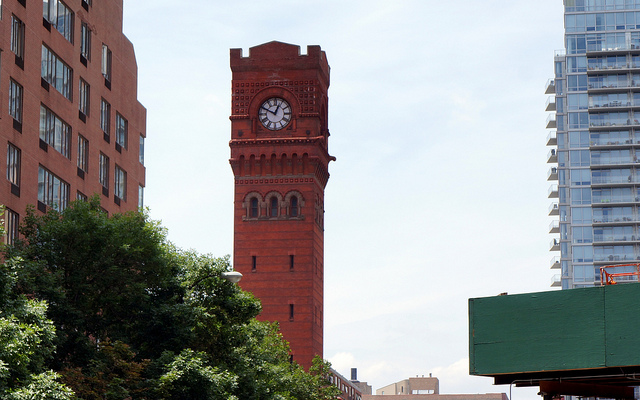How many arched windows under the clock?
Answer the question using a single word or phrase. 3 Is the time correct? Yes Is this clock tower functional? Yes 